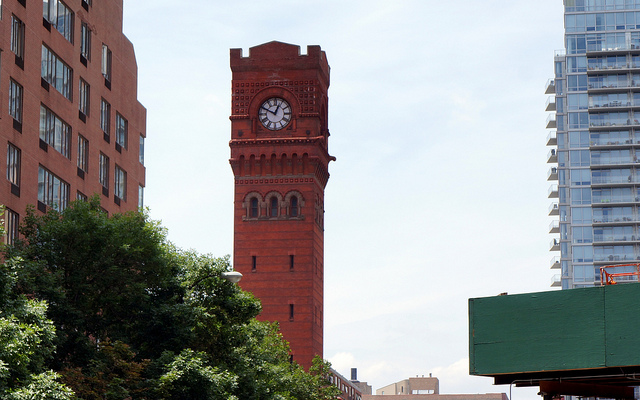How many arched windows under the clock?
Answer the question using a single word or phrase. 3 Is the time correct? Yes Is this clock tower functional? Yes 